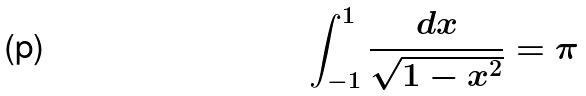<formula> <loc_0><loc_0><loc_500><loc_500>\int _ { - 1 } ^ { 1 } \frac { d x } { \sqrt { 1 - x ^ { 2 } } } = \pi</formula> 